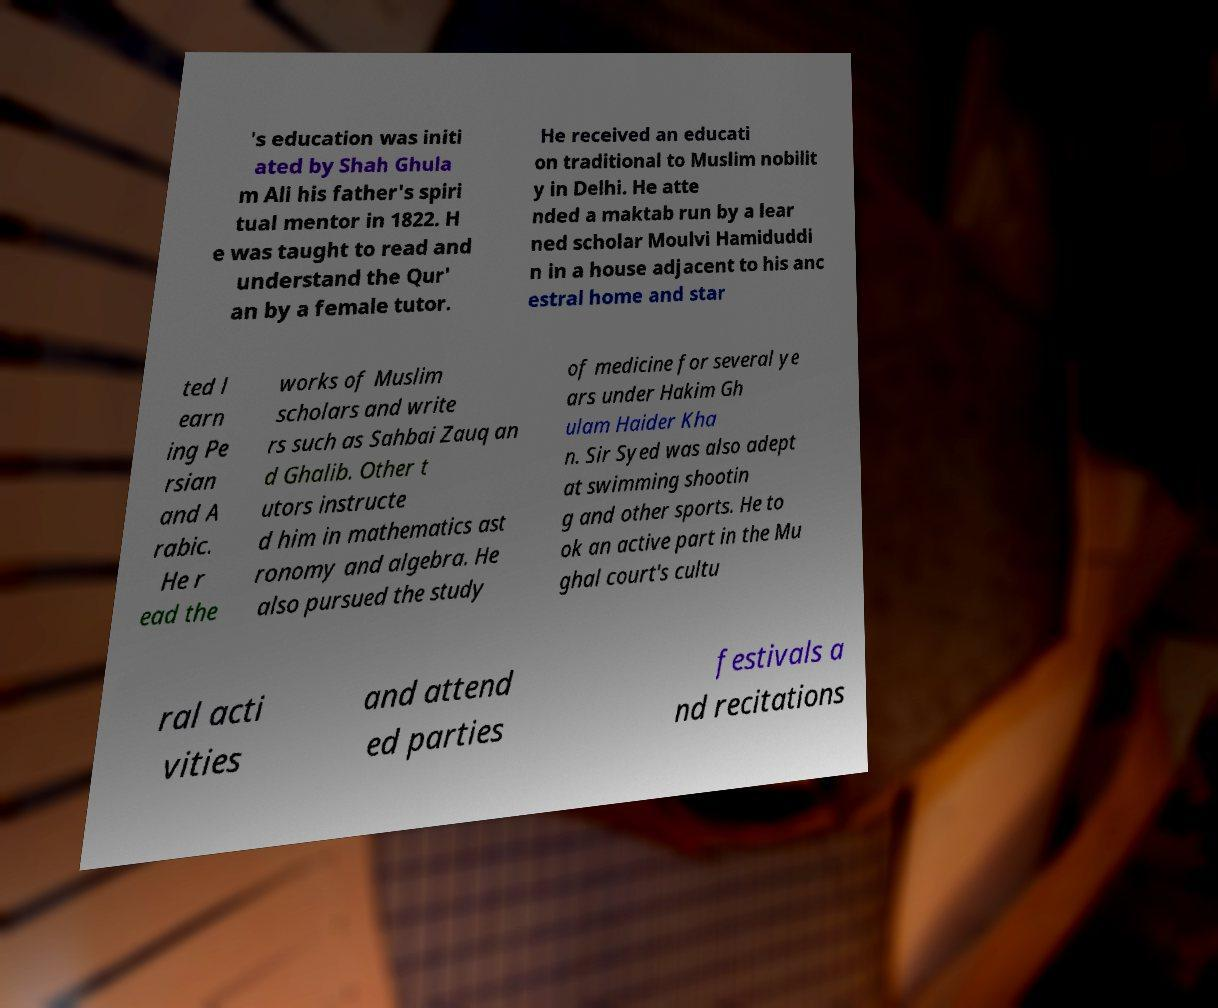Can you read and provide the text displayed in the image?This photo seems to have some interesting text. Can you extract and type it out for me? 's education was initi ated by Shah Ghula m Ali his father's spiri tual mentor in 1822. H e was taught to read and understand the Qur' an by a female tutor. He received an educati on traditional to Muslim nobilit y in Delhi. He atte nded a maktab run by a lear ned scholar Moulvi Hamiduddi n in a house adjacent to his anc estral home and star ted l earn ing Pe rsian and A rabic. He r ead the works of Muslim scholars and write rs such as Sahbai Zauq an d Ghalib. Other t utors instructe d him in mathematics ast ronomy and algebra. He also pursued the study of medicine for several ye ars under Hakim Gh ulam Haider Kha n. Sir Syed was also adept at swimming shootin g and other sports. He to ok an active part in the Mu ghal court's cultu ral acti vities and attend ed parties festivals a nd recitations 